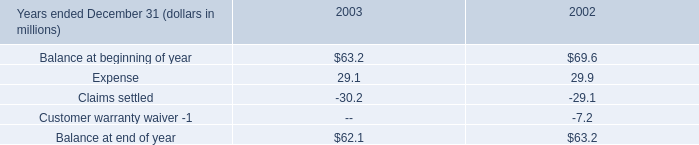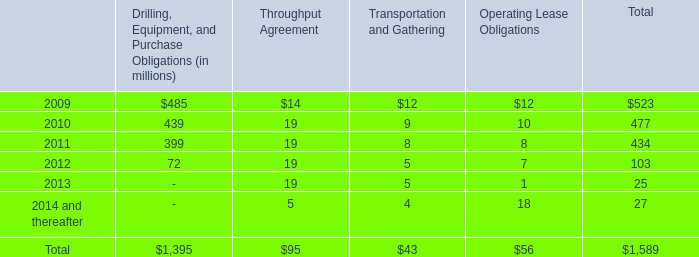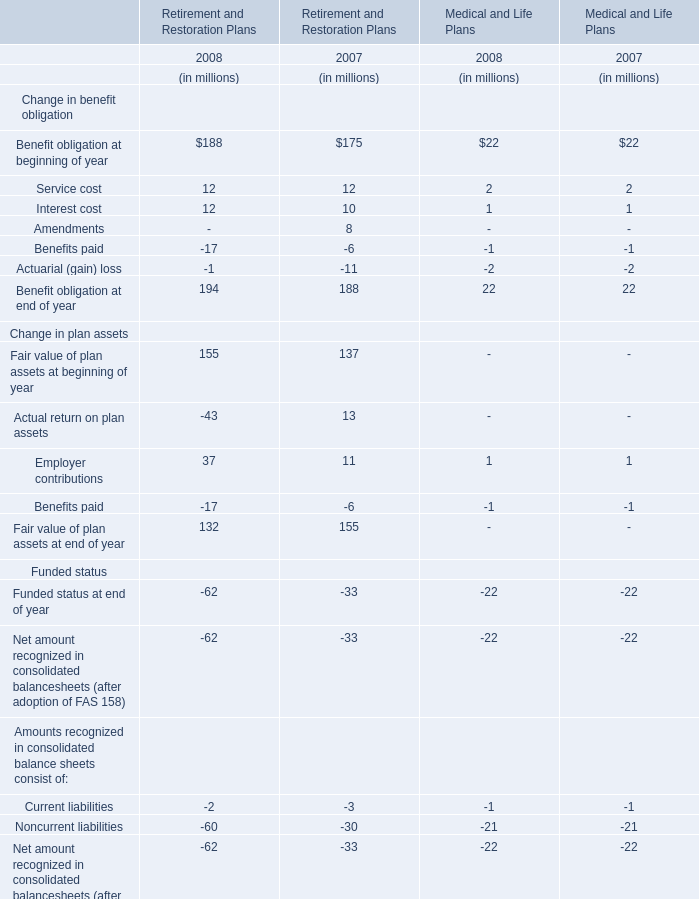what was the percentage change in research and development costs between 2001 and 2002? 
Computations: ((30.4 - 27.6) / 27.6)
Answer: 0.10145. 